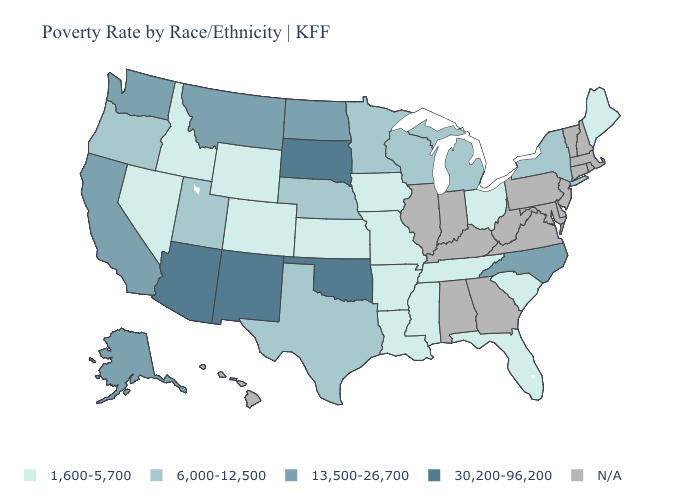Does the map have missing data?
Concise answer only. Yes. What is the highest value in states that border California?
Concise answer only. 30,200-96,200. How many symbols are there in the legend?
Be succinct. 5. How many symbols are there in the legend?
Concise answer only. 5. What is the value of California?
Quick response, please. 13,500-26,700. What is the value of Kansas?
Answer briefly. 1,600-5,700. What is the value of Delaware?
Quick response, please. N/A. What is the value of Oklahoma?
Give a very brief answer. 30,200-96,200. Which states have the highest value in the USA?
Short answer required. Arizona, New Mexico, Oklahoma, South Dakota. Does Maine have the lowest value in the USA?
Write a very short answer. Yes. Among the states that border Alabama , which have the lowest value?
Quick response, please. Florida, Mississippi, Tennessee. What is the value of Wisconsin?
Quick response, please. 6,000-12,500. What is the value of Mississippi?
Short answer required. 1,600-5,700. 